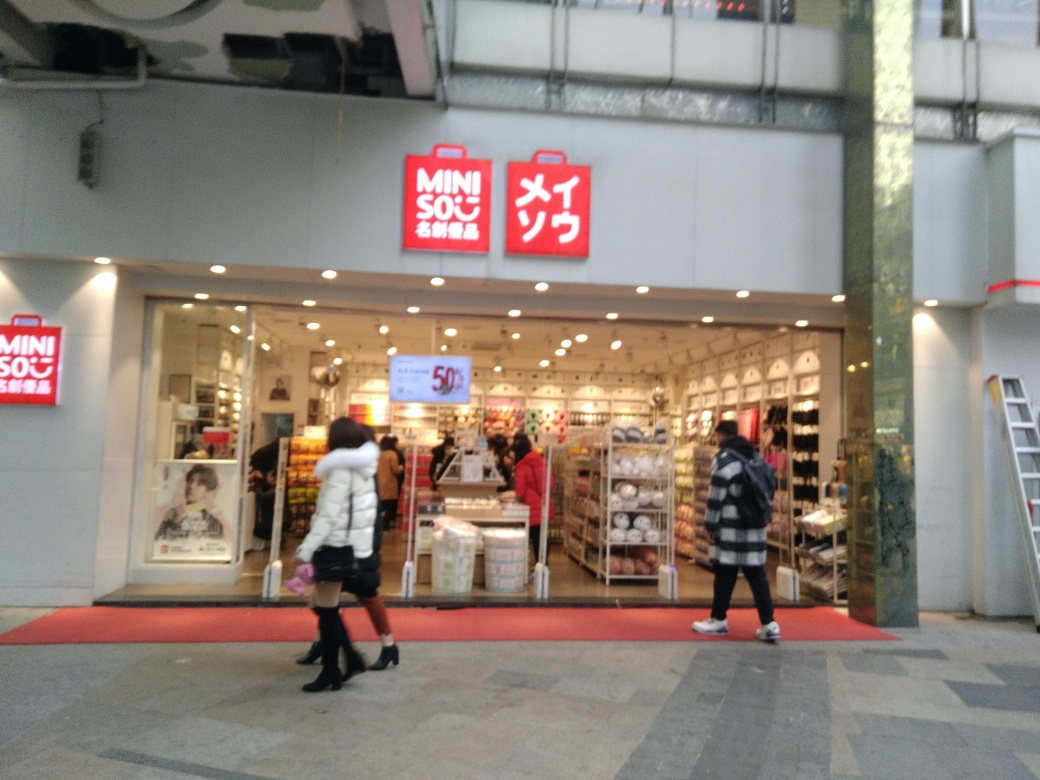What kind of products does the store in the image appear to sell? The store showcased in the image seems to offer a wide variety of goods. Through the glass storefront, we can see shelves and displays featuring household items, possibly including kitchenware, bathroom accessories, and various storage solutions. The establishment presents itself as a place where customers might find everyday essentials for home organization and decor. 